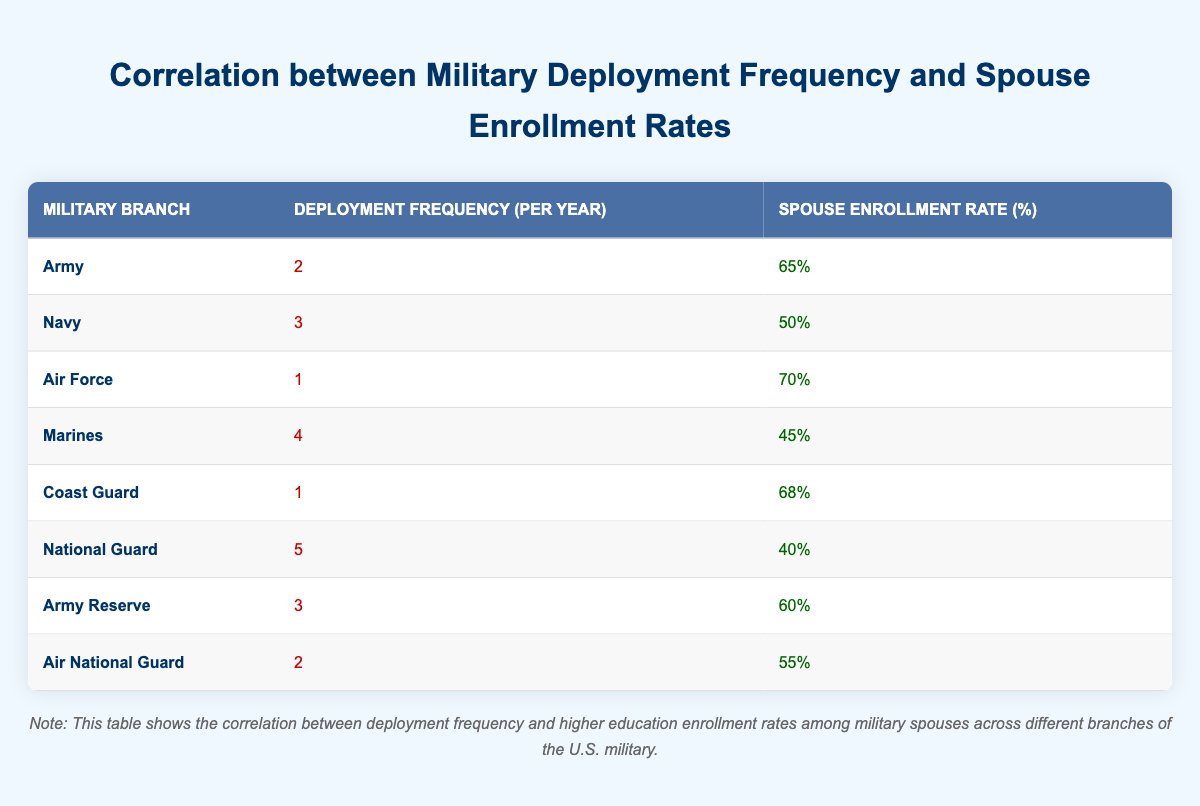What is the enrollment rate for the Air Force? The table lists the enrollment rates for each military branch. For the Air Force, the enrollment rate is found in the corresponding row, which indicates it is 70%.
Answer: 70% What is the deployment frequency of the National Guard? In the table, looking specifically at the National Guard row, the deployment frequency is 5.
Answer: 5 Which military branch has the highest enrollment rate, and what is that rate? To identify the highest enrollment rate, I’ll compare all the enrollment rates listed. Upon reviewing, the Air Force has the highest enrollment rate at 70%.
Answer: Air Force, 70% What is the average enrollment rate across all branches represented in the table? First, I’ll sum all the enrollment rates: 65 + 50 + 70 + 45 + 68 + 40 + 60 + 55 = 450. There are 8 branches, so I divide the total by 8: 450 / 8 = 56.25.
Answer: 56.25 Is the enrollment rate for the Marines higher than that for the Army? The enrollment rate for the Marines is 45%, and for the Army, it is 65%. Since 45% is less than 65%, the statement is false.
Answer: No Which military branch has the lowest deployment frequency and what is its enrollment rate? By checking the deployment frequencies, the Air Force and Coast Guard have the lowest deployment frequency at 1. I then look at their enrollment rates, which are 70% and 68%, respectively. Therefore, the Coast Guard is identified with a lower deployment frequency at 1 and its enrollment rate is 68%.
Answer: Coast Guard, 68% Is it true that the enrollment rate decreases as deployment frequency increases? I will examine the deployment frequencies and corresponding enrollment rates. From the data, a clear pattern cannot be accurately established between these variables as there are higher enrollment rates at both ends. For example, the National Guard with the highest deployment frequency (5) has a lower enrollment rate (40%), but the Air Force (1 deployment) has a higher enrollment rate (70%). Therefore, it's not necessarily true.
Answer: No What is the difference in enrollment rate between the Army and the Navy? The Army's enrollment rate is 65% and the Navy's is 50%. To find the difference, I calculate 65% - 50% = 15%.
Answer: 15% 